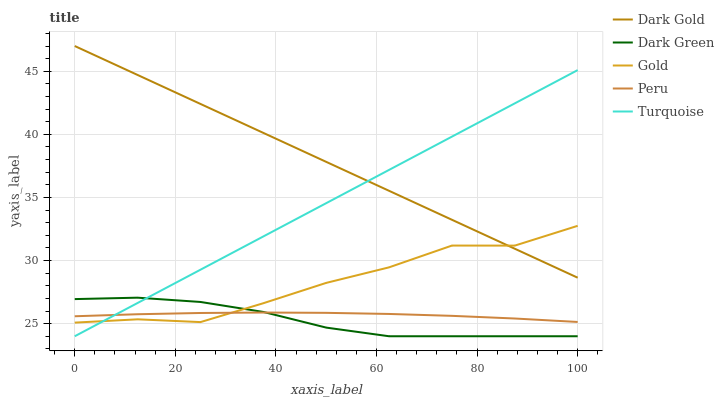Does Peru have the minimum area under the curve?
Answer yes or no. No. Does Peru have the maximum area under the curve?
Answer yes or no. No. Is Dark Green the smoothest?
Answer yes or no. No. Is Dark Green the roughest?
Answer yes or no. No. Does Peru have the lowest value?
Answer yes or no. No. Does Dark Green have the highest value?
Answer yes or no. No. Is Dark Green less than Dark Gold?
Answer yes or no. Yes. Is Dark Gold greater than Peru?
Answer yes or no. Yes. Does Dark Green intersect Dark Gold?
Answer yes or no. No. 